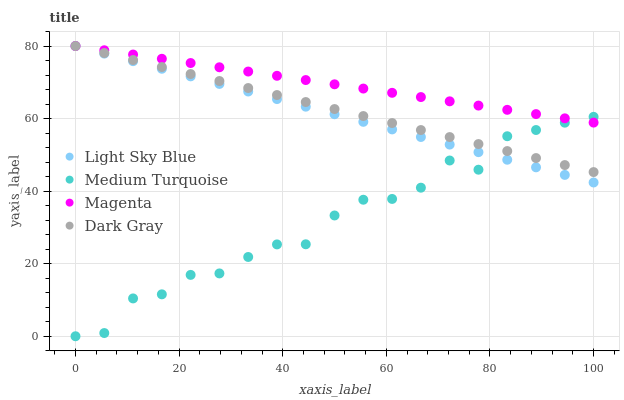Does Medium Turquoise have the minimum area under the curve?
Answer yes or no. Yes. Does Magenta have the maximum area under the curve?
Answer yes or no. Yes. Does Light Sky Blue have the minimum area under the curve?
Answer yes or no. No. Does Light Sky Blue have the maximum area under the curve?
Answer yes or no. No. Is Light Sky Blue the smoothest?
Answer yes or no. Yes. Is Medium Turquoise the roughest?
Answer yes or no. Yes. Is Magenta the smoothest?
Answer yes or no. No. Is Magenta the roughest?
Answer yes or no. No. Does Medium Turquoise have the lowest value?
Answer yes or no. Yes. Does Light Sky Blue have the lowest value?
Answer yes or no. No. Does Light Sky Blue have the highest value?
Answer yes or no. Yes. Does Medium Turquoise have the highest value?
Answer yes or no. No. Does Dark Gray intersect Magenta?
Answer yes or no. Yes. Is Dark Gray less than Magenta?
Answer yes or no. No. Is Dark Gray greater than Magenta?
Answer yes or no. No. 